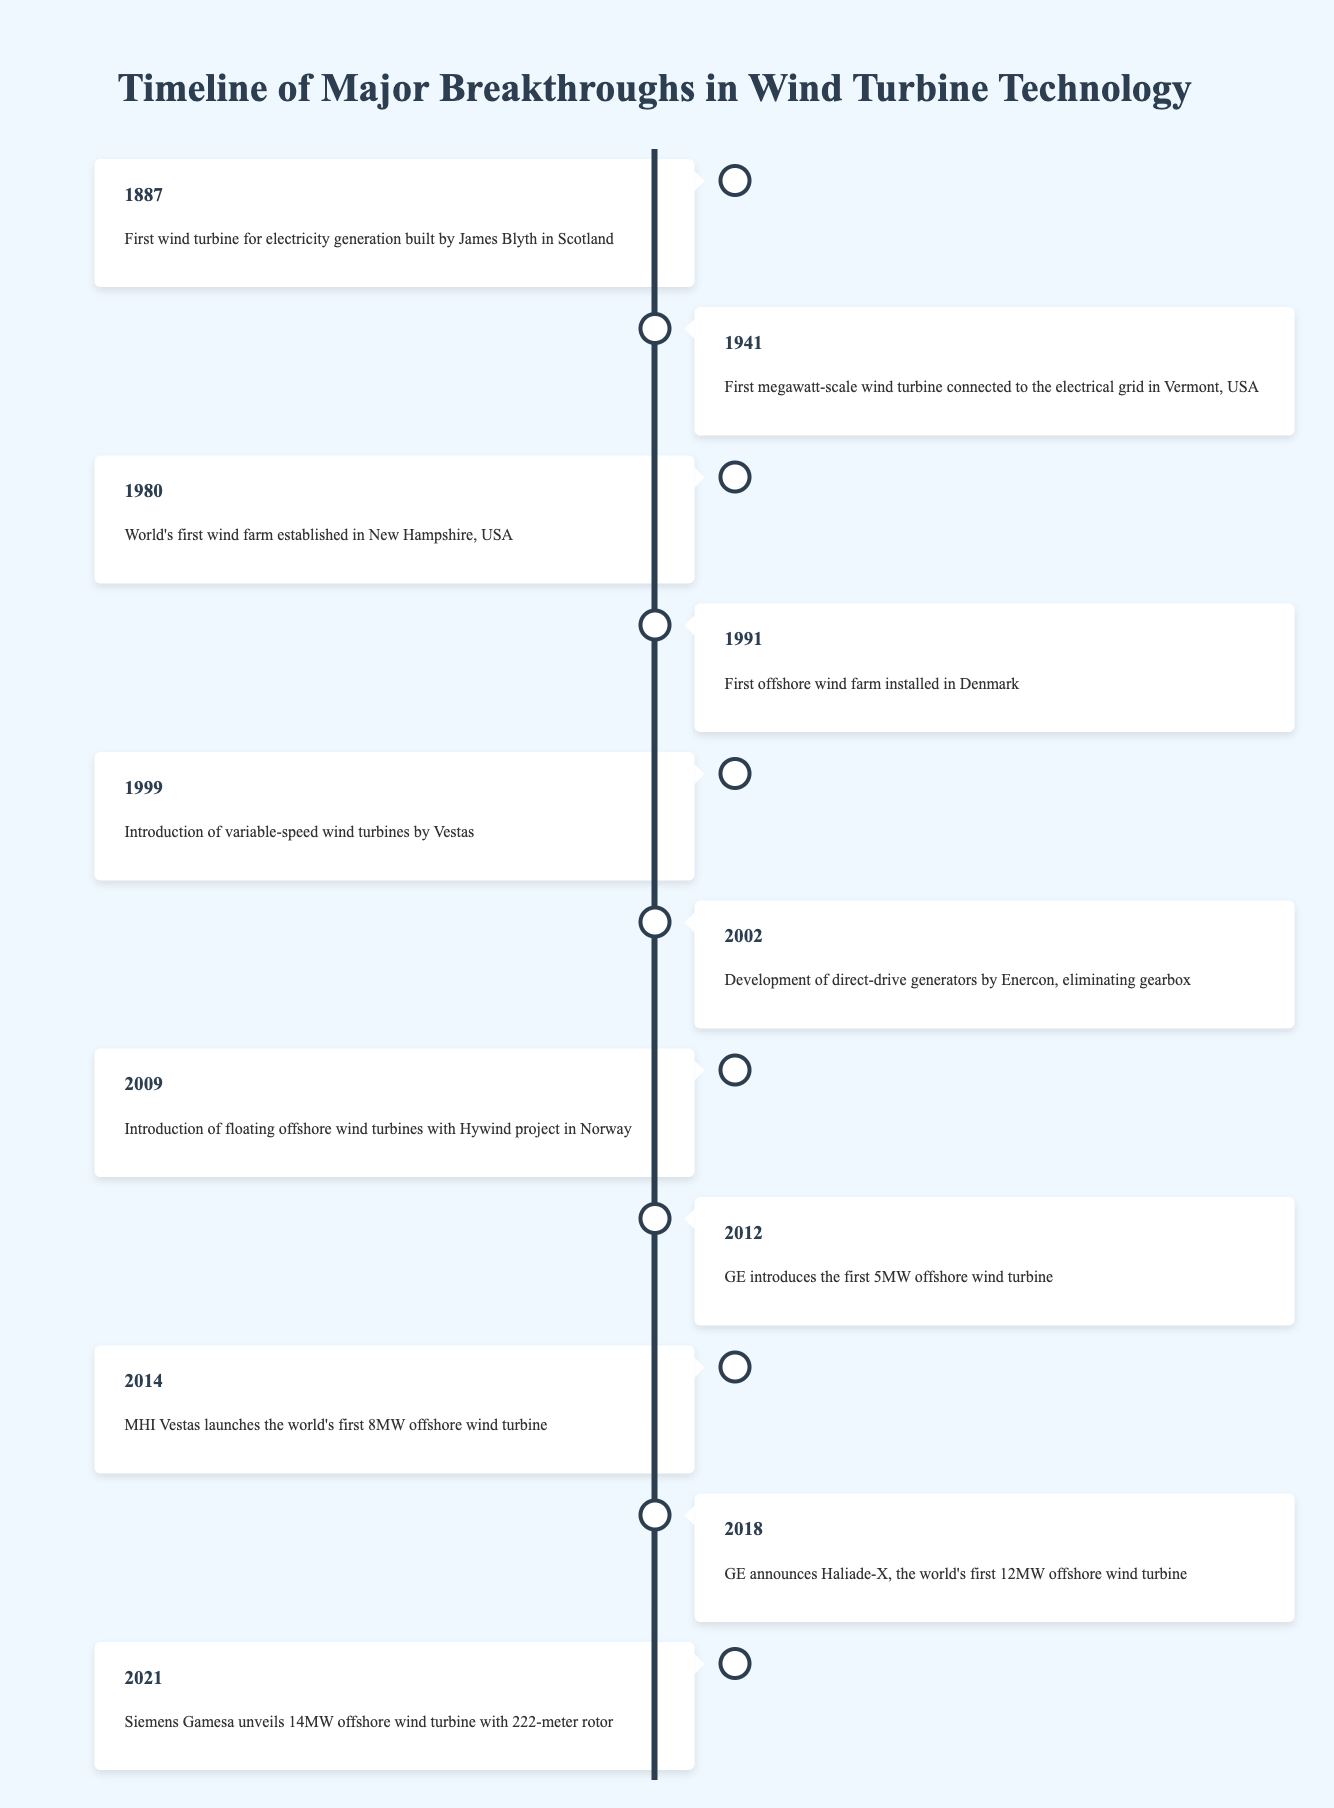What year was the first wind turbine for electricity generation built? The timeline indicates that the first wind turbine for electricity generation was built by James Blyth in Scotland in 1887.
Answer: 1887 How many years passed between the first megawatt-scale wind turbine and the first offshore wind farm? The first megawatt-scale wind turbine was connected to the electrical grid in 1941, and the first offshore wind farm was installed in 1991. The difference is 1991 - 1941 = 50 years.
Answer: 50 years Was the world's first wind farm established before or after 1990? The timeline states that the world's first wind farm was established in 1980. Since 1980 is before 1990, the answer is yes.
Answer: Yes Which company introduced the first 5MW offshore wind turbine? According to the timeline, GE introduced the first 5MW offshore wind turbine in 2012.
Answer: GE What is the average year of the milestones listed in the timeline? To calculate the average year, sum the years (1887 + 1941 + 1980 + 1991 + 1999 + 2002 + 2009 + 2012 + 2014 + 2018 + 2021 =  20544) and divide by the number of events (11): 20544 / 11 = 1868.545. The average year is approximately 2002.
Answer: 2002 How many breakthroughs occurred in offshore wind turbine technology by 2018? There are three events listed specifically related to offshore wind turbines: 1991 (first offshore wind farm), 2012 (first 5MW offshore wind turbine), and 2018 (Haliade-X, the first 12MW offshore wind turbine). Therefore, the total is three.
Answer: 3 Did any wind turbine technology breakthroughs occur in the 2000s? The timeline lists two events in the 2000s: the development of direct-drive generators in 2002 and the introduction of floating offshore wind turbines in 2009, confirming that breakthroughs did occur in this decade.
Answer: Yes Which breakthrough in wind turbine technology had the largest capacity? The timeline indicates that Siemens Gamesa unveiled a 14MW offshore wind turbine in 2021, representing the largest capacity breakthrough mentioned.
Answer: 14MW 